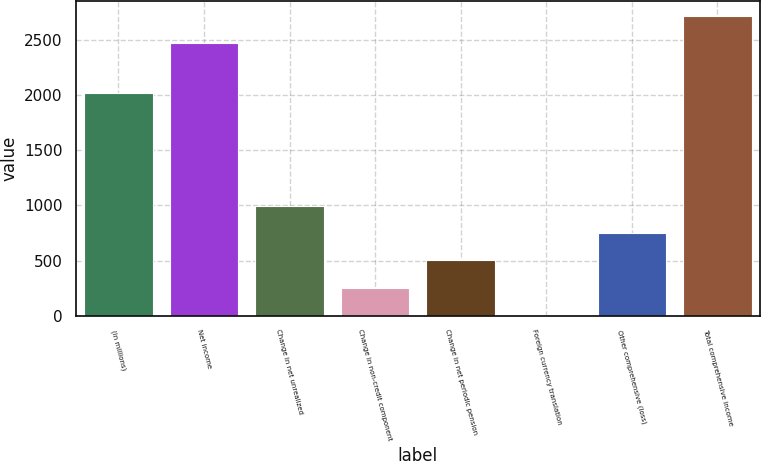<chart> <loc_0><loc_0><loc_500><loc_500><bar_chart><fcel>(in millions)<fcel>Net income<fcel>Change in net unrealized<fcel>Change in non-credit component<fcel>Change in net periodic pension<fcel>Foreign currency translation<fcel>Other comprehensive (loss)<fcel>Total comprehensive income<nl><fcel>2016<fcel>2470<fcel>999.2<fcel>251.3<fcel>500.6<fcel>2<fcel>749.9<fcel>2719.3<nl></chart> 